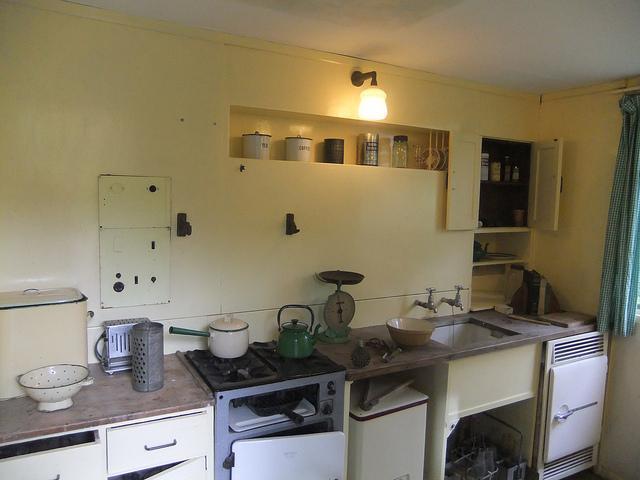What is the white bowl with holes in it on the left used for?
Choose the correct response and explain in the format: 'Answer: answer
Rationale: rationale.'
Options: Mashing, straining, mixing, tenderizing. Answer: straining.
Rationale: You can pour things that have liquid that needs drained out into it. 